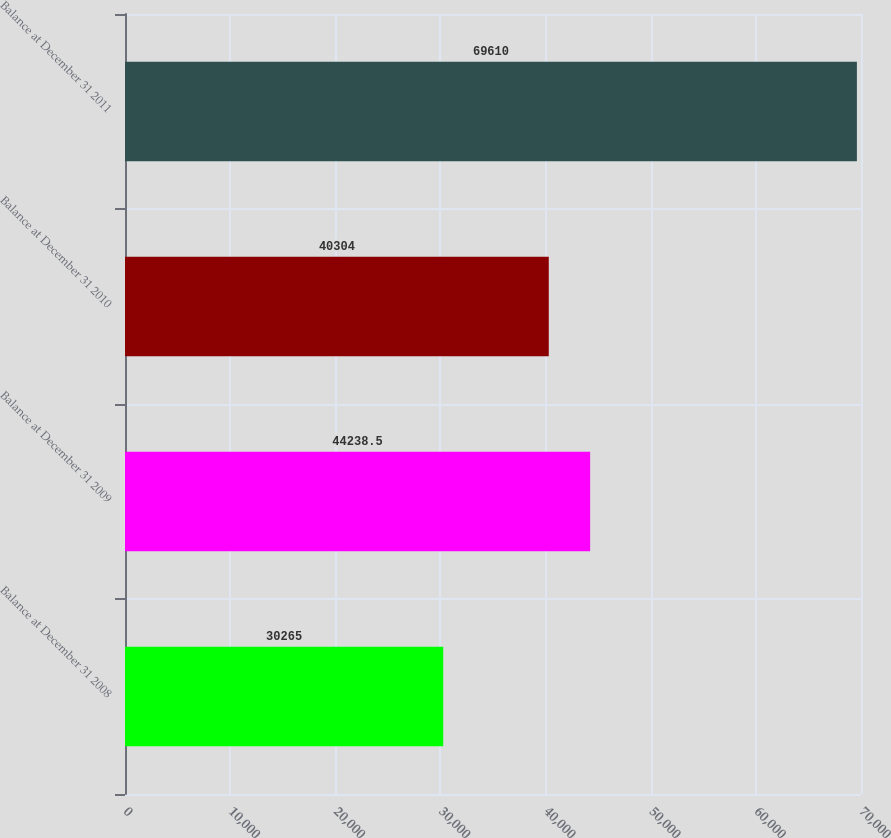Convert chart to OTSL. <chart><loc_0><loc_0><loc_500><loc_500><bar_chart><fcel>Balance at December 31 2008<fcel>Balance at December 31 2009<fcel>Balance at December 31 2010<fcel>Balance at December 31 2011<nl><fcel>30265<fcel>44238.5<fcel>40304<fcel>69610<nl></chart> 